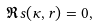<formula> <loc_0><loc_0><loc_500><loc_500>\Re s ( \kappa , r ) = 0 ,</formula> 